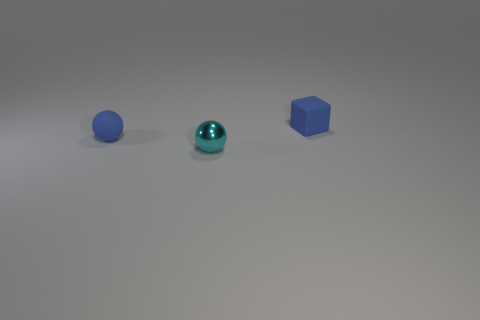Subtract all yellow blocks. Subtract all gray cylinders. How many blocks are left? 1 Add 1 small cyan spheres. How many objects exist? 4 Subtract all cubes. How many objects are left? 2 Subtract all small blue spheres. Subtract all tiny red matte cubes. How many objects are left? 2 Add 1 cyan spheres. How many cyan spheres are left? 2 Add 1 small blue rubber balls. How many small blue rubber balls exist? 2 Subtract 0 brown cylinders. How many objects are left? 3 